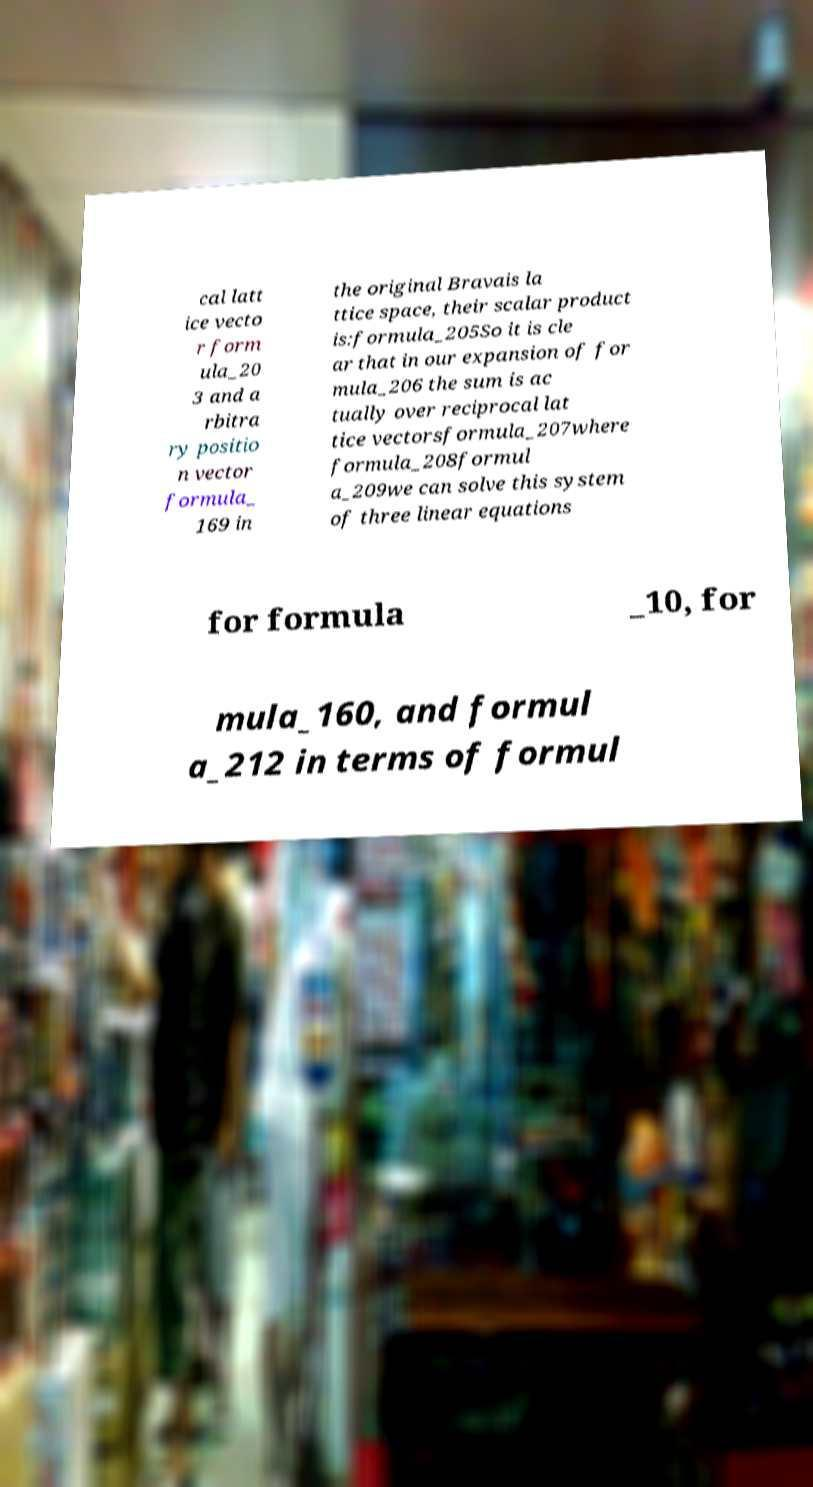Can you accurately transcribe the text from the provided image for me? cal latt ice vecto r form ula_20 3 and a rbitra ry positio n vector formula_ 169 in the original Bravais la ttice space, their scalar product is:formula_205So it is cle ar that in our expansion of for mula_206 the sum is ac tually over reciprocal lat tice vectorsformula_207where formula_208formul a_209we can solve this system of three linear equations for formula _10, for mula_160, and formul a_212 in terms of formul 